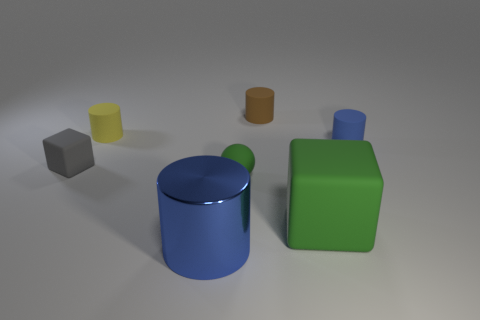Could you infer any potential uses for these objects based on their shapes? Sure, based on their shapes, the cylinders could serve as containers or holders of some sort, perhaps as vases or jars if they are hollow. The cube could function as a paperweight or a decorative item, and the green rectangular prism could be a storage box or a building block for larger constructions. However, it's important to note that without additional context or scale, these are just speculative uses. 